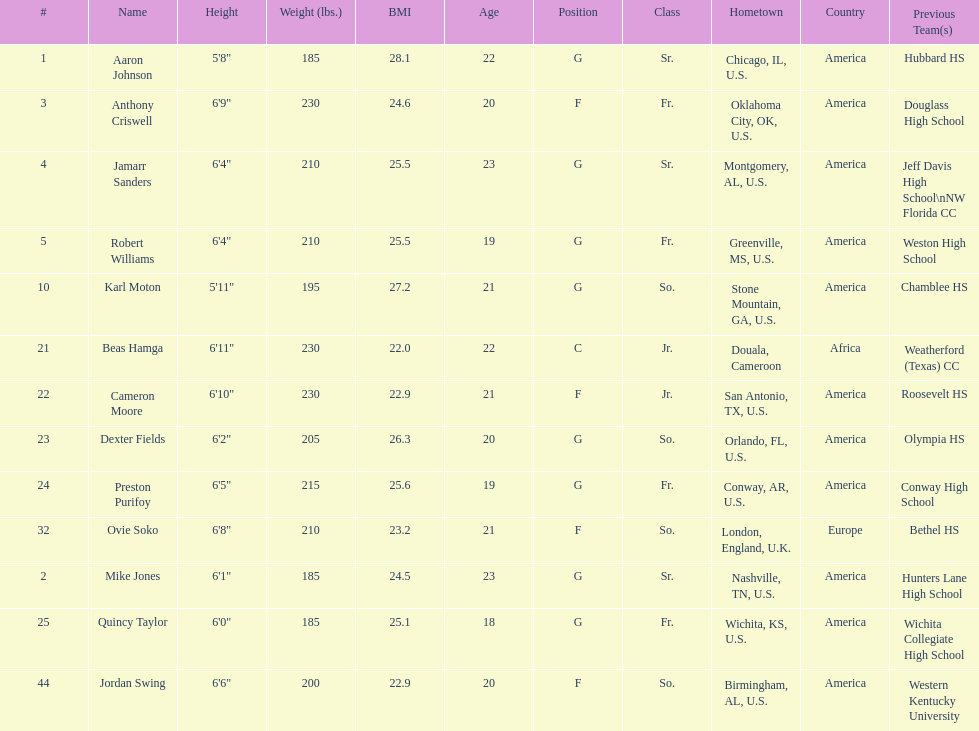How many players were on the 2010-11 uab blazers men's basketball team? 13. 